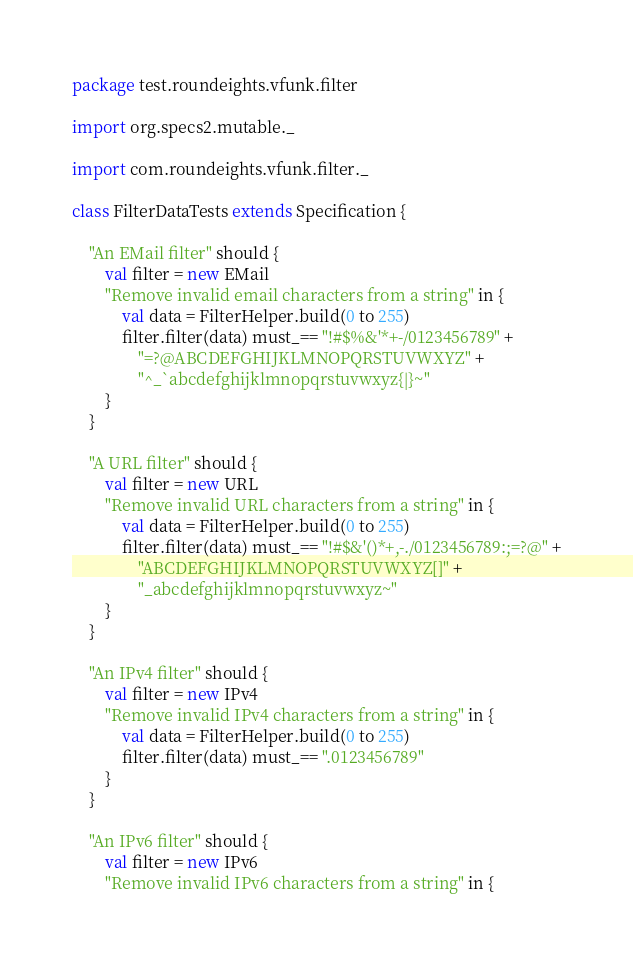<code> <loc_0><loc_0><loc_500><loc_500><_Scala_>package test.roundeights.vfunk.filter

import org.specs2.mutable._

import com.roundeights.vfunk.filter._

class FilterDataTests extends Specification {

    "An EMail filter" should {
        val filter = new EMail
        "Remove invalid email characters from a string" in {
            val data = FilterHelper.build(0 to 255)
            filter.filter(data) must_== "!#$%&'*+-/0123456789" +
                "=?@ABCDEFGHIJKLMNOPQRSTUVWXYZ" +
                "^_`abcdefghijklmnopqrstuvwxyz{|}~"
        }
    }

    "A URL filter" should {
        val filter = new URL
        "Remove invalid URL characters from a string" in {
            val data = FilterHelper.build(0 to 255)
            filter.filter(data) must_== "!#$&'()*+,-./0123456789:;=?@" +
                "ABCDEFGHIJKLMNOPQRSTUVWXYZ[]" +
                "_abcdefghijklmnopqrstuvwxyz~"
        }
    }

    "An IPv4 filter" should {
        val filter = new IPv4
        "Remove invalid IPv4 characters from a string" in {
            val data = FilterHelper.build(0 to 255)
            filter.filter(data) must_== ".0123456789"
        }
    }

    "An IPv6 filter" should {
        val filter = new IPv6
        "Remove invalid IPv6 characters from a string" in {</code> 